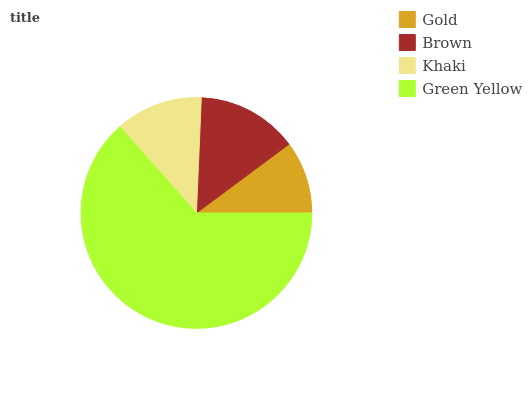Is Gold the minimum?
Answer yes or no. Yes. Is Green Yellow the maximum?
Answer yes or no. Yes. Is Brown the minimum?
Answer yes or no. No. Is Brown the maximum?
Answer yes or no. No. Is Brown greater than Gold?
Answer yes or no. Yes. Is Gold less than Brown?
Answer yes or no. Yes. Is Gold greater than Brown?
Answer yes or no. No. Is Brown less than Gold?
Answer yes or no. No. Is Brown the high median?
Answer yes or no. Yes. Is Khaki the low median?
Answer yes or no. Yes. Is Khaki the high median?
Answer yes or no. No. Is Green Yellow the low median?
Answer yes or no. No. 